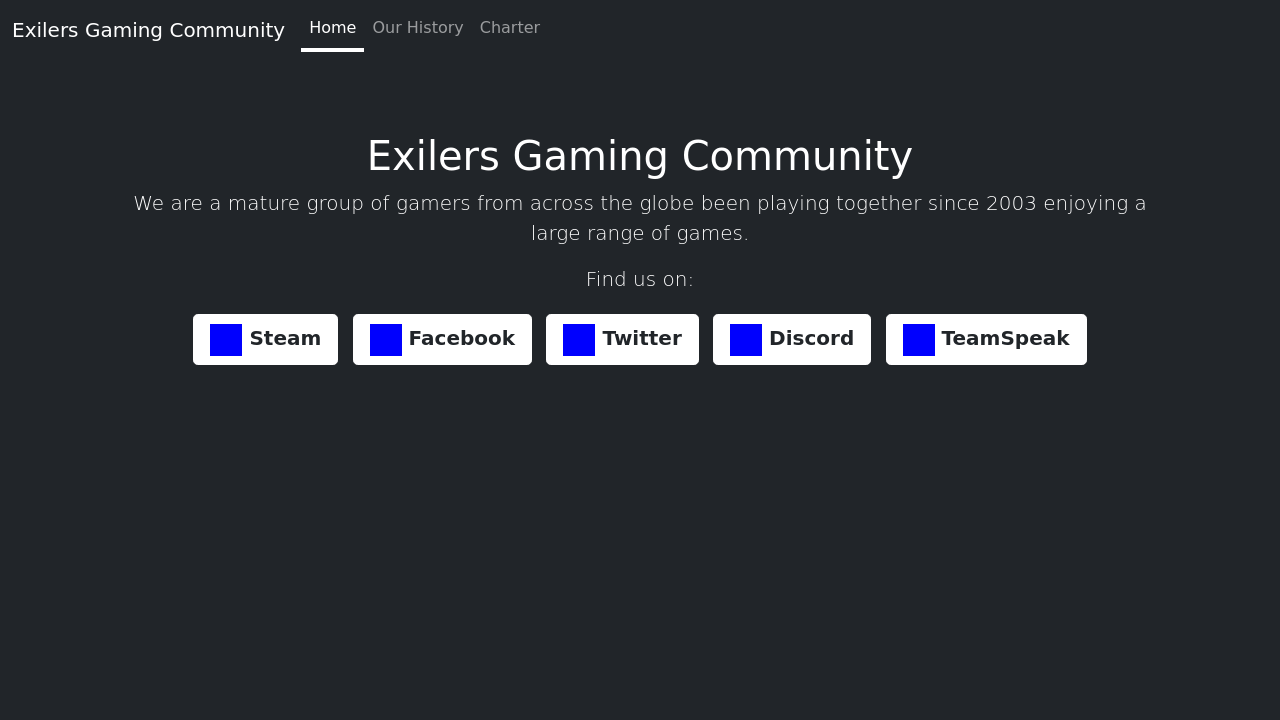Could you detail the process for assembling this website using HTML? <!DOCTYPE html>
<html lang='en'>
<head>
    <meta charset='UTF-8'>
    <meta name='viewport' content='width=device-width, initial-scale=1.0'>
    <title>Exilers Gaming Community</title>
    <link rel='stylesheet' href='https://stackpath.bootstrapcdn.com/bootstrap/4.3.1/css/bootstrap.min.css'>
    <style>
        body { background-color: #343a40; color: white; }
        .container { margin-top: 20px; }
        .btn-custom { background-color: #424242; border-color: #ffffff; }
    </style>
</head>
<body>
    <nav class='navbar navbar-expand-lg navbar-dark bg-dark'>
        <a class='navbar-brand' href='#'>Exilers Gaming Community</a>
        <button class='navbar-toggler' type='button' data-toggle='collapse' data-target='#navbarNav' aria-controls='navbarNav' aria-expanded='false' aria-label='Toggle navigation'>
            <span class='navbar-toggler-icon'></span>
        </button>
        <div class='collapse navbar-collapse' id='navbarNav'>
            <ul class='navbar-nav'>
                <li class='nav-item active'>
                    <a class='nav-link' href='#'>Home <span class='sr-only'>(current)</span></a>
                </li>
                <li class='nav-item'>
                    <a class='nav-link' href='#'>Our History</a>
                </li>
                <li class='nav-item'>
                    <a class='nav-link' href='#'>Charter</a>
                </li>
            </ul>
        </div>
    </nav>
    <div class='container text-center'>
        <h1>Welcome to the Exilers Gaming Community</h1>
        <p class='lead'>Join us to explore various games together, make friends, and have fun!</p>
        <div>
            <a href='https://steamcommunity.com' class='btn btn-custom btn-lg'>Steam</a>
            <a href='https://facebook.com' class='btn btn-custom btn-lg'>Facebook</a>
            <a href='https://twitter.com' class='btn btn-custom btn-lg'>Twitter</a>
            <a href='https://discord.gg' class='btn btn-custom btn-lg'>Discord</a>
            <a href='https://teamspeak.com' class='btn btn-custom btn-lg'>TeamSpeak</a>
        </div>
    </div>
</body>
</html> 